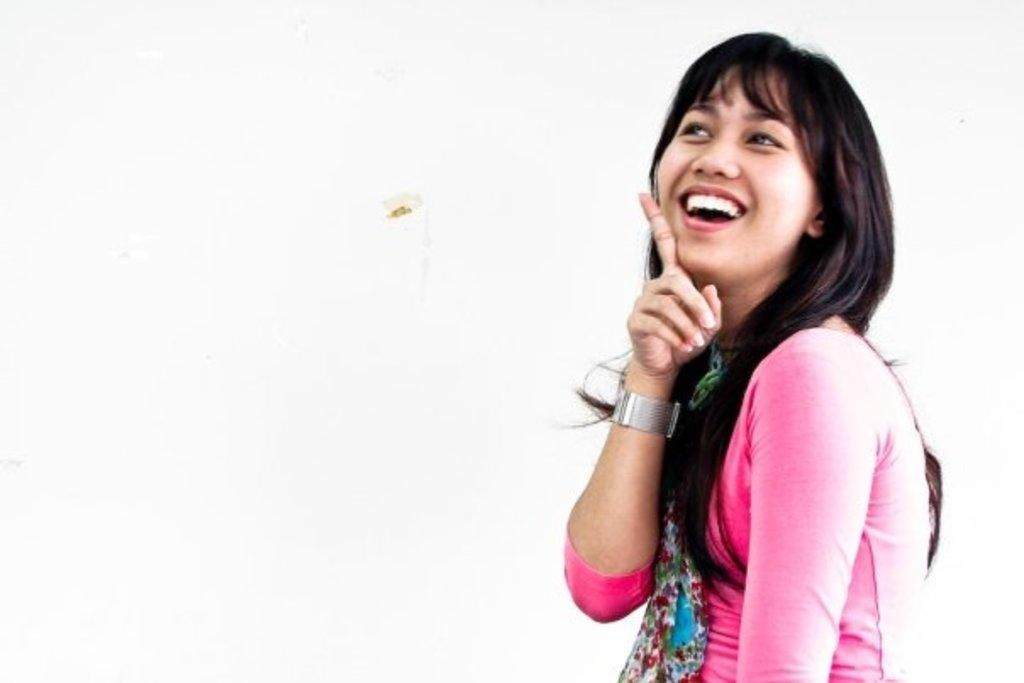Who or what is the main subject in the image? There is a person in the image. What is the person wearing? The person is wearing a pink and blue color dress. What color is the background of the image? The background of the image is white. What type of legal advice is the person providing in the image? There is no indication in the image that the person is providing legal advice or is a lawyer. 